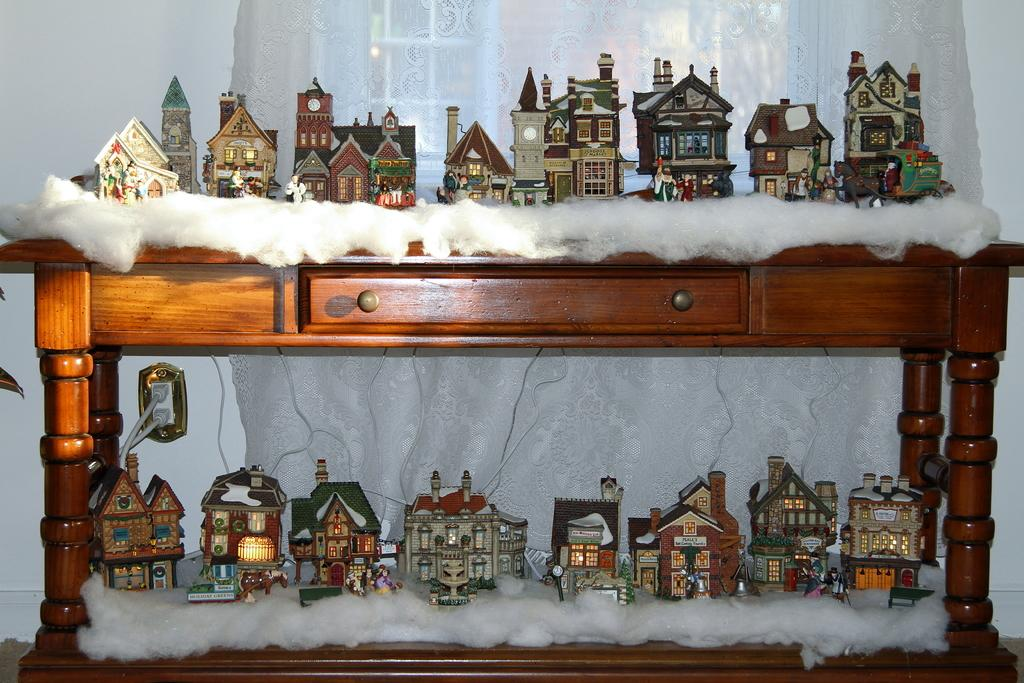What is the main object on the table in the image? There are scale model houses on the table in the image. What material is present on and around the table? Cotton is present on and around the table. What can be seen hanging in the image? There is a curtain visible in the image. What type of wiring is present in the image? Cables are present in the image. What is visible in the background of the image? There is a wall in the background of the image. Can you tell me how many boats are visible in the image? There are no boats present in the image. What type of chain is used to secure the model houses to the table? There is no chain present in the image; the model houses are not secured to the table. 